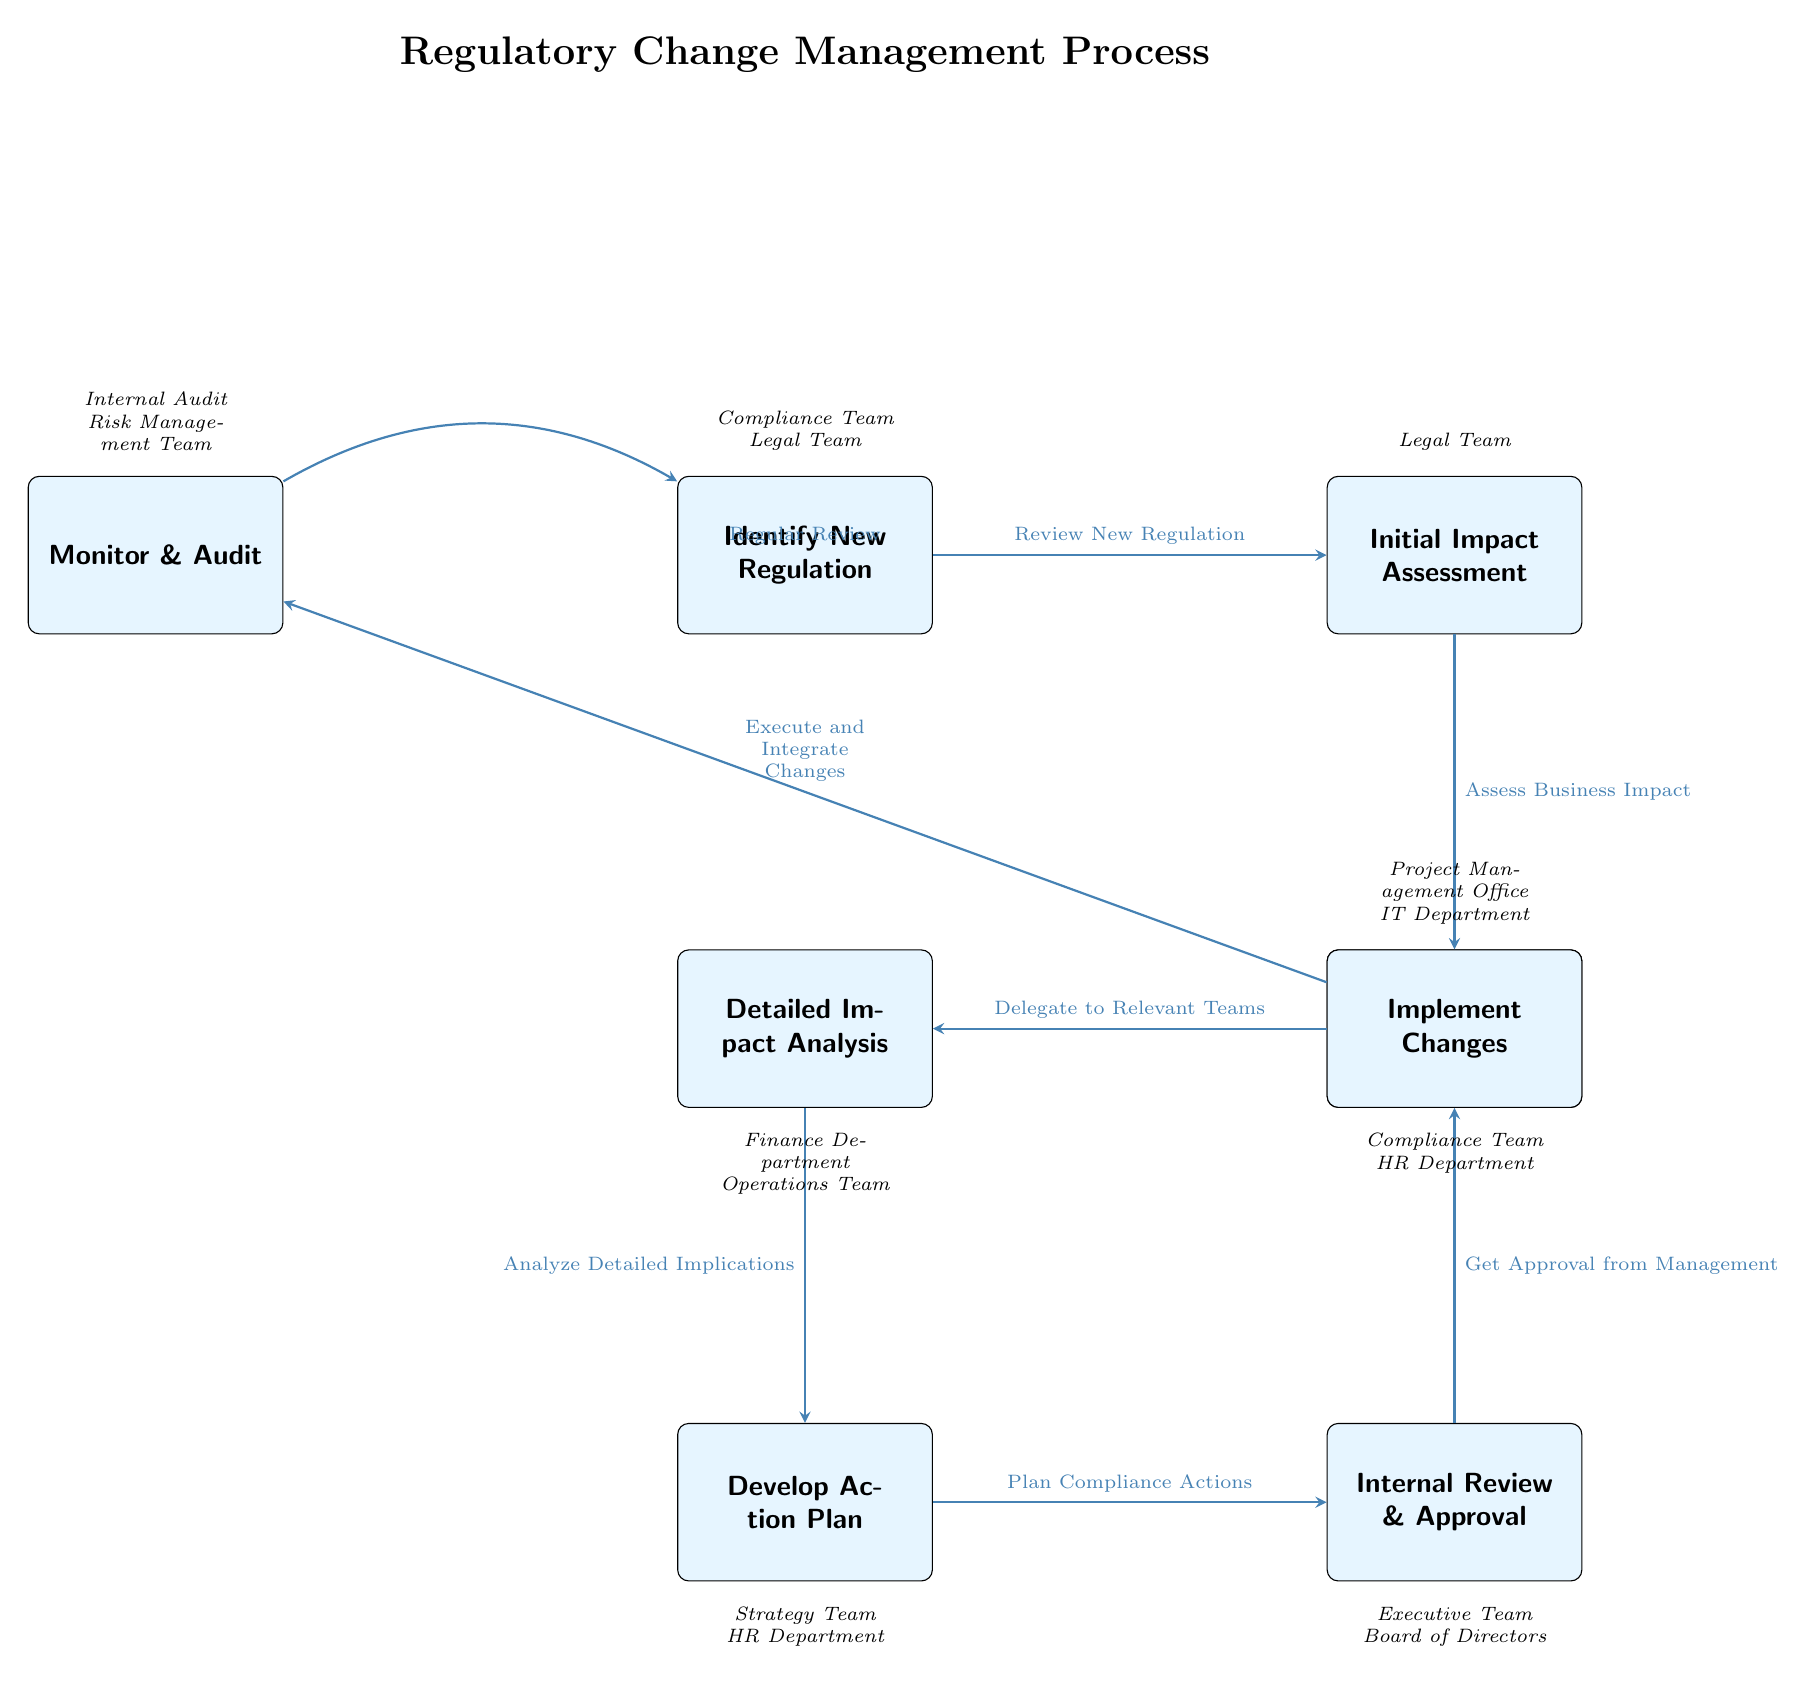What is the first step in the regulatory change management process? The first step is identified by the node labeled "Identify New Regulation" which introduces the process.
Answer: Identify New Regulation How many total steps are shown in the diagram? The diagram lists a total of eight distinct steps or nodes involved in the regulatory change management process.
Answer: Eight Which stakeholder is involved in the "Initial Impact Assessment"? The diagram specifies that the "Legal Team" is the main stakeholder associated with the "Initial Impact Assessment" step.
Answer: Legal Team What action follows the "Develop Action Plan"? The diagram indicates that after "Develop Action Plan", the next action is "Internal Review & Approval".
Answer: Internal Review & Approval Which node indicates the responsibility for analyzing detailed implications? The node "Detailed Impact Analysis" signifies the step responsible for analyzing the detailed implications of the new regulation.
Answer: Detailed Impact Analysis What is the direction of the flow from "Implement Changes"? The flow directs from "Implement Changes" to "Monitor & Audit", indicating that the subsequent action is to monitor the changes after implementation.
Answer: Monitor & Audit What is the role of the "Compliance Team" in the process? The "Compliance Team" is responsible for "Assign Responsibility" and is also noted as a stakeholder in "Identify New Regulation" and "Monitor & Audit".
Answer: Assign Responsibility Which decision is made after assessing the business impact? After assessing the business impact, the decision made is to "Delegate to Relevant Teams" indicated by the arrow from "Initial Impact Assessment" to "Assign Responsibility".
Answer: Delegate to Relevant Teams What is a recurring action indicated in the diagram? The action "Regular Review" is indicated as a continual process that connects back to the initial step, suggesting an ongoing evaluation of regulations.
Answer: Regular Review 